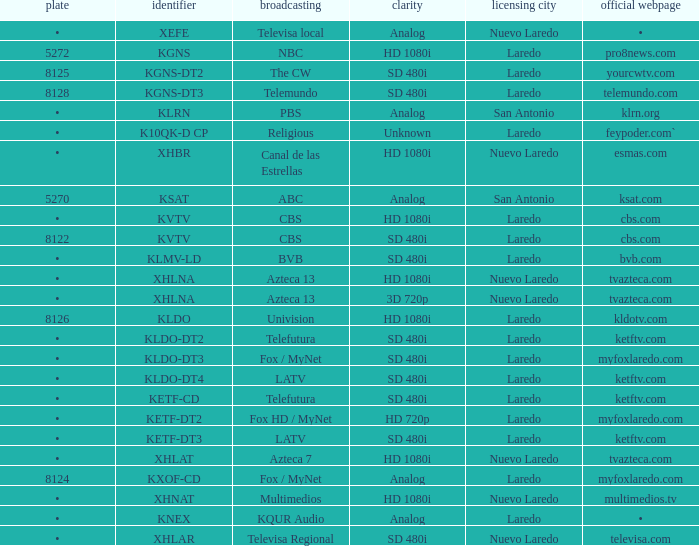Name the dish for resolution of sd 480i and network of bvb •. 